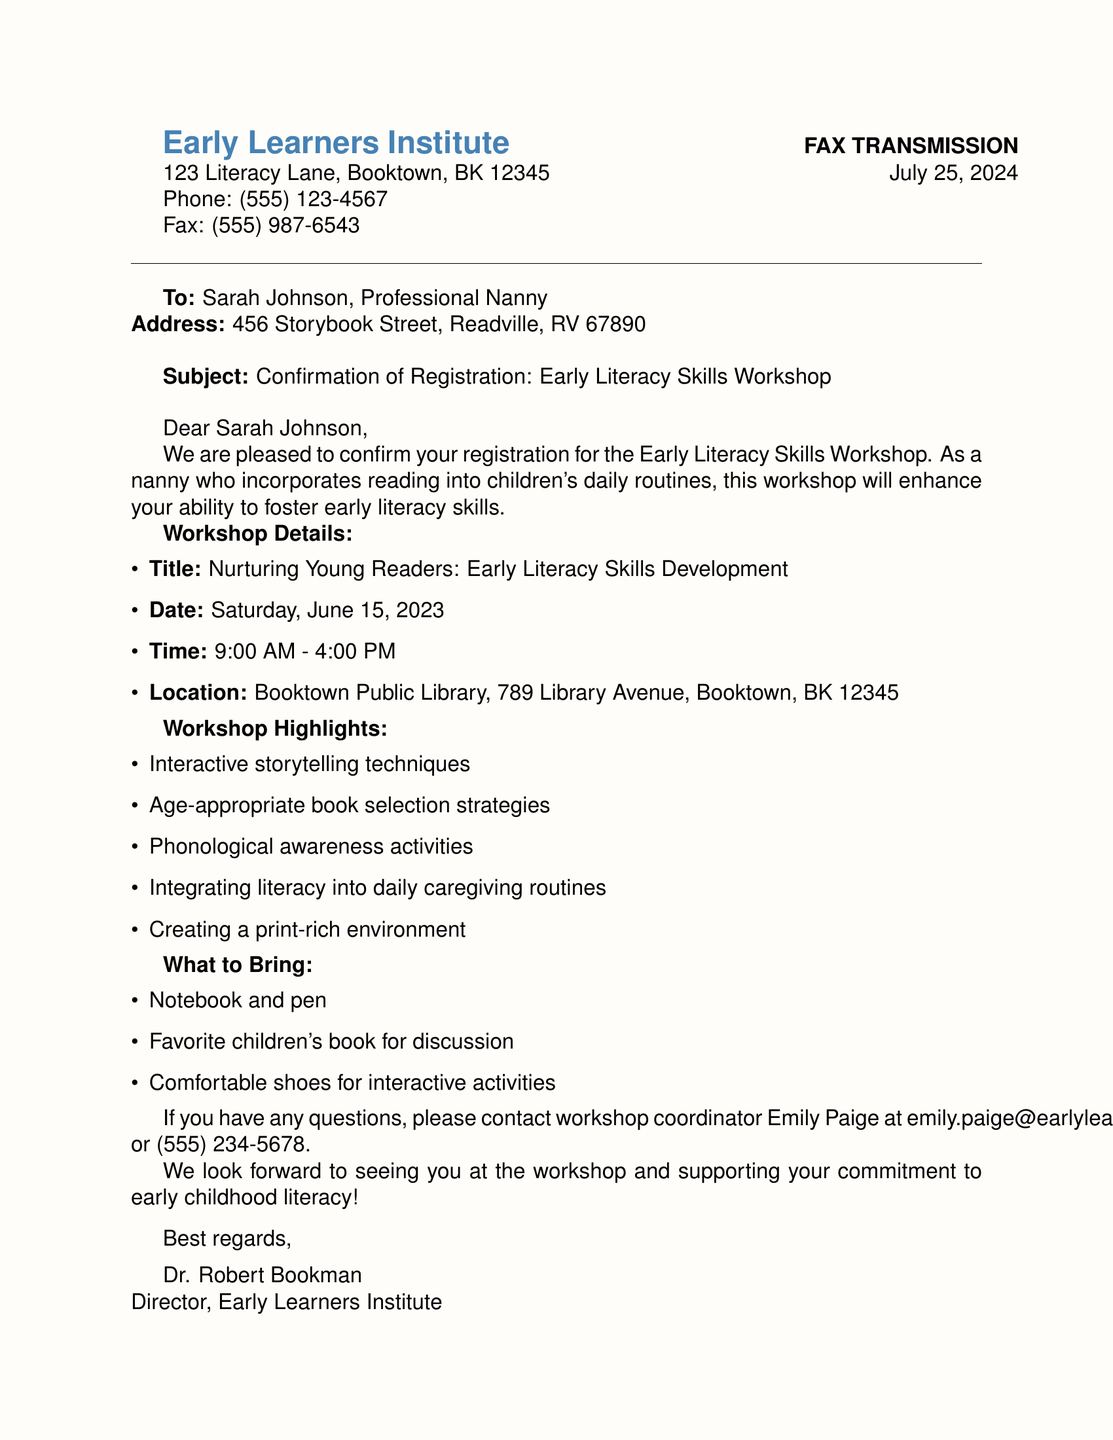What is the name of the workshop? The name of the workshop is stated in the document as "Nurturing Young Readers: Early Literacy Skills Development."
Answer: Nurturing Young Readers: Early Literacy Skills Development What is the date of the workshop? The document specifies that the workshop is on Saturday, June 15, 2023.
Answer: Saturday, June 15, 2023 What time does the workshop start? The document indicates that the workshop starts at 9:00 AM.
Answer: 9:00 AM Who is the workshop coordinator? The document lists Emily Paige as the workshop coordinator.
Answer: Emily Paige What should attendees bring? The document mentions several items; one of them is a favorite children's book.
Answer: Favorite children's book for discussion What is the location of the workshop? The workshop's location is provided in the document as Booktown Public Library, 789 Library Avenue, Booktown, BK 12345.
Answer: Booktown Public Library, 789 Library Avenue, Booktown, BK 12345 What is one highlight of the workshop? The document states that one workshop highlight is "Interactive storytelling techniques."
Answer: Interactive storytelling techniques How long is the workshop scheduled to last? The start time is at 9:00 AM and the end time is at 4:00 PM, indicating the length is 7 hours.
Answer: 7 hours 